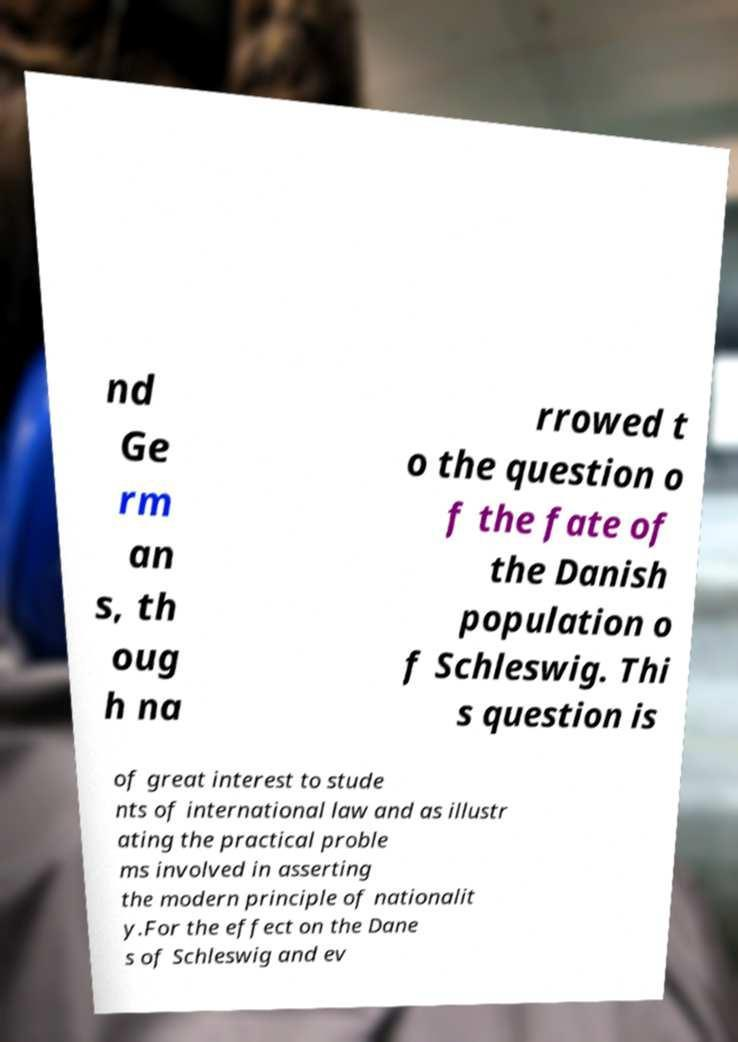Please identify and transcribe the text found in this image. nd Ge rm an s, th oug h na rrowed t o the question o f the fate of the Danish population o f Schleswig. Thi s question is of great interest to stude nts of international law and as illustr ating the practical proble ms involved in asserting the modern principle of nationalit y.For the effect on the Dane s of Schleswig and ev 